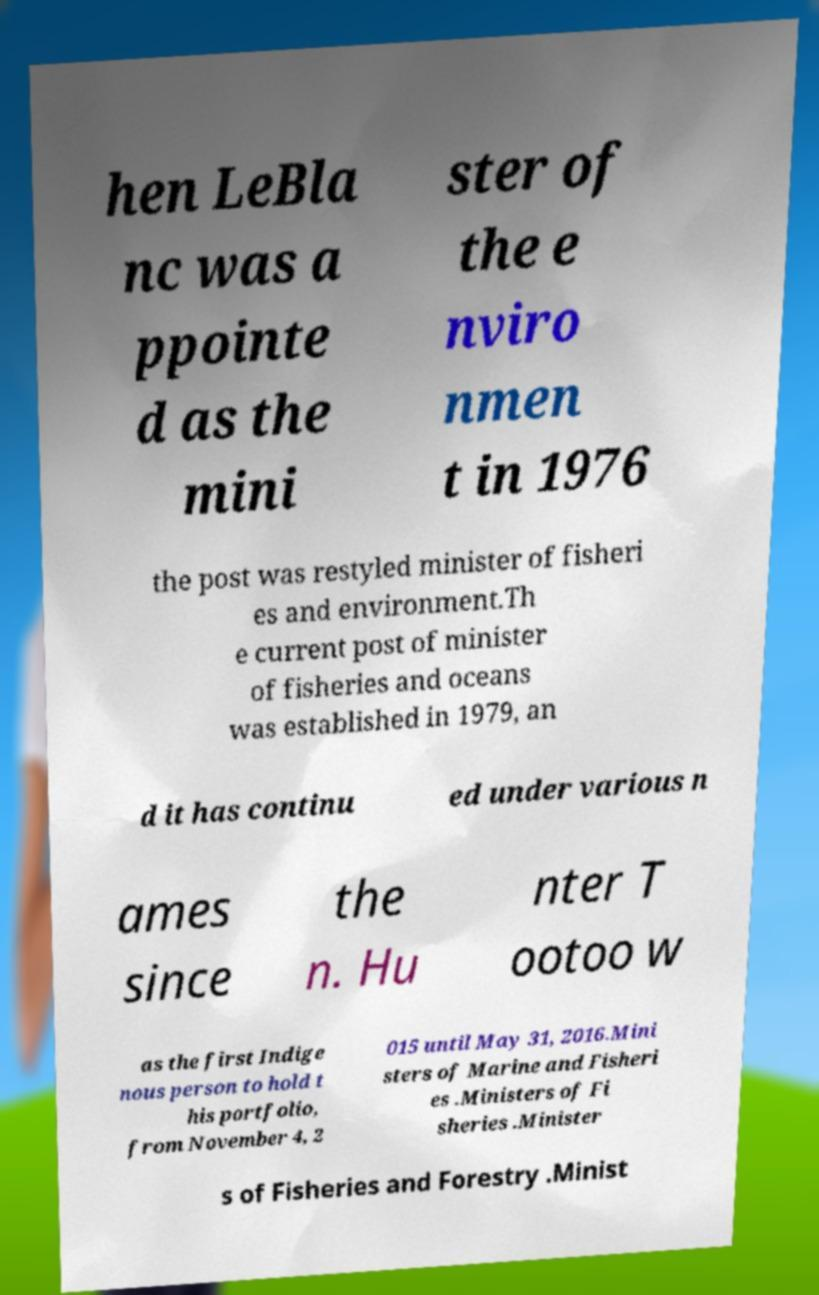For documentation purposes, I need the text within this image transcribed. Could you provide that? hen LeBla nc was a ppointe d as the mini ster of the e nviro nmen t in 1976 the post was restyled minister of fisheri es and environment.Th e current post of minister of fisheries and oceans was established in 1979, an d it has continu ed under various n ames since the n. Hu nter T ootoo w as the first Indige nous person to hold t his portfolio, from November 4, 2 015 until May 31, 2016.Mini sters of Marine and Fisheri es .Ministers of Fi sheries .Minister s of Fisheries and Forestry .Minist 